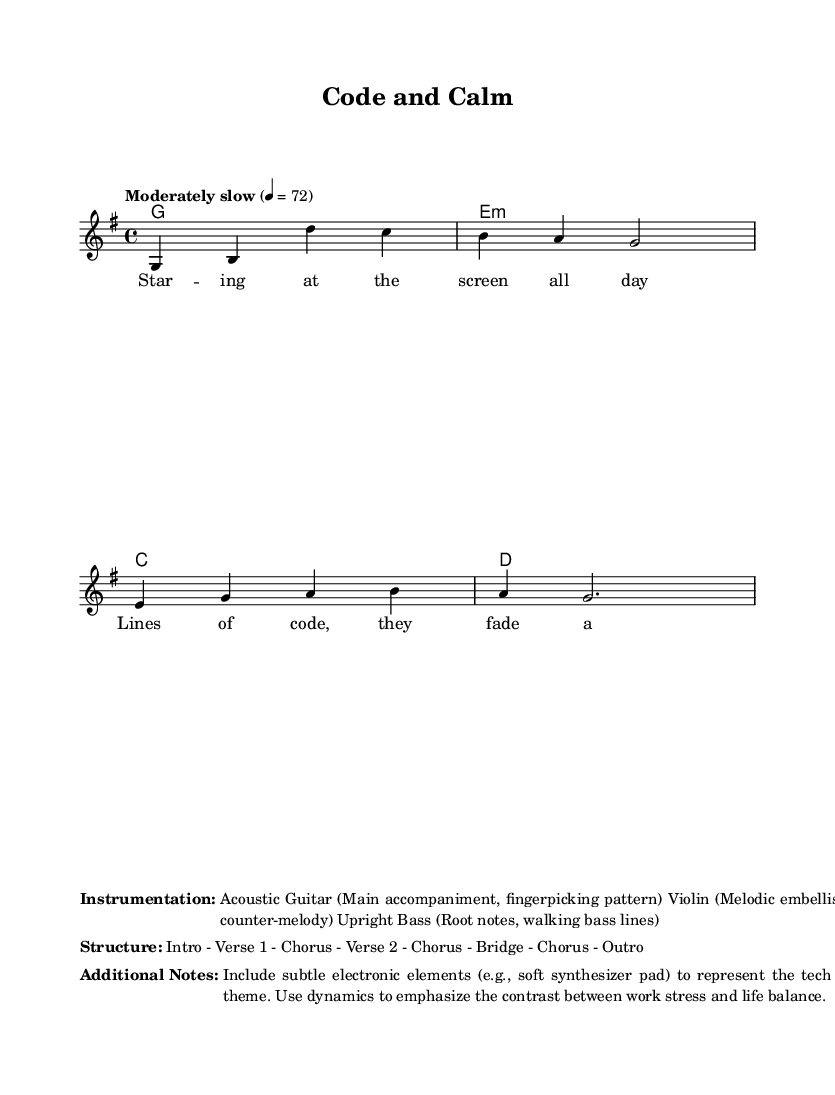What is the key signature of this music? The key signature shown in the score indicates that it is in G major, which has one sharp (F#). This can be identified at the beginning of the staff, where the sharp sign is placed on the F line of the treble staff.
Answer: G major What is the time signature of this music? The time signature given in the music is 4/4, which is indicated at the beginning of the score. This means there are four beats in each measure and the quarter note is the beat unit.
Answer: 4/4 What is the tempo marking of this music? The tempo marking, found at the start of the score, indicates the music should be played at a moderately slow pace of 72 beats per minute. This is indicated by the text "Moderately slow" followed by the tempo marking.
Answer: 72 What is the structure of the song? The structure of the song as indicated in the markup includes several sections arranged as Intro - Verse 1 - Chorus - Verse 2 - Chorus - Bridge - Chorus - Outro. This information helps in understanding how the song is organized.
Answer: Intro - Verse 1 - Chorus - Verse 2 - Chorus - Bridge - Chorus - Outro How many voices are present in this music? The score shows that there is one primary voice labeled as "lead" for the melody, and the chords below provide harmonic support. The staff indicates there are also chord names but they do not count as separate voices.
Answer: One What instrumentation is used in this track? The markup details the instrumentation used in the arrangement: Acoustic Guitar (for main accompaniment), Violin (for melodic embellishments), and Upright Bass (for root notes). This is important for understanding the texture of the music.
Answer: Acoustic Guitar, Violin, Upright Bass What thematic element is suggested in the additional notes? The additional notes indicate the inclusion of subtle electronic elements to represent the theme of the tech industry, along with dynamics used to emphasize the contrast between work stress and life balance. This helps connect the music to its thematic content.
Answer: Tech industry theme 